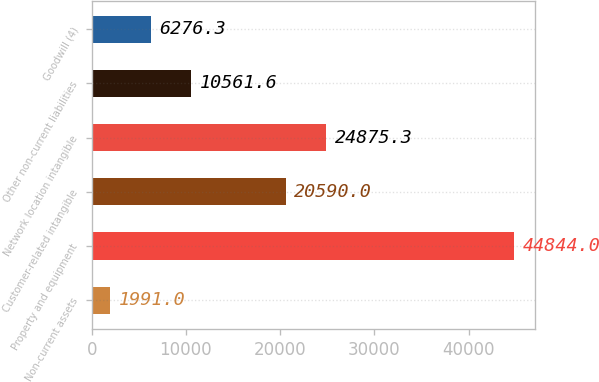<chart> <loc_0><loc_0><loc_500><loc_500><bar_chart><fcel>Non-current assets<fcel>Property and equipment<fcel>Customer-related intangible<fcel>Network location intangible<fcel>Other non-current liabilities<fcel>Goodwill (4)<nl><fcel>1991<fcel>44844<fcel>20590<fcel>24875.3<fcel>10561.6<fcel>6276.3<nl></chart> 